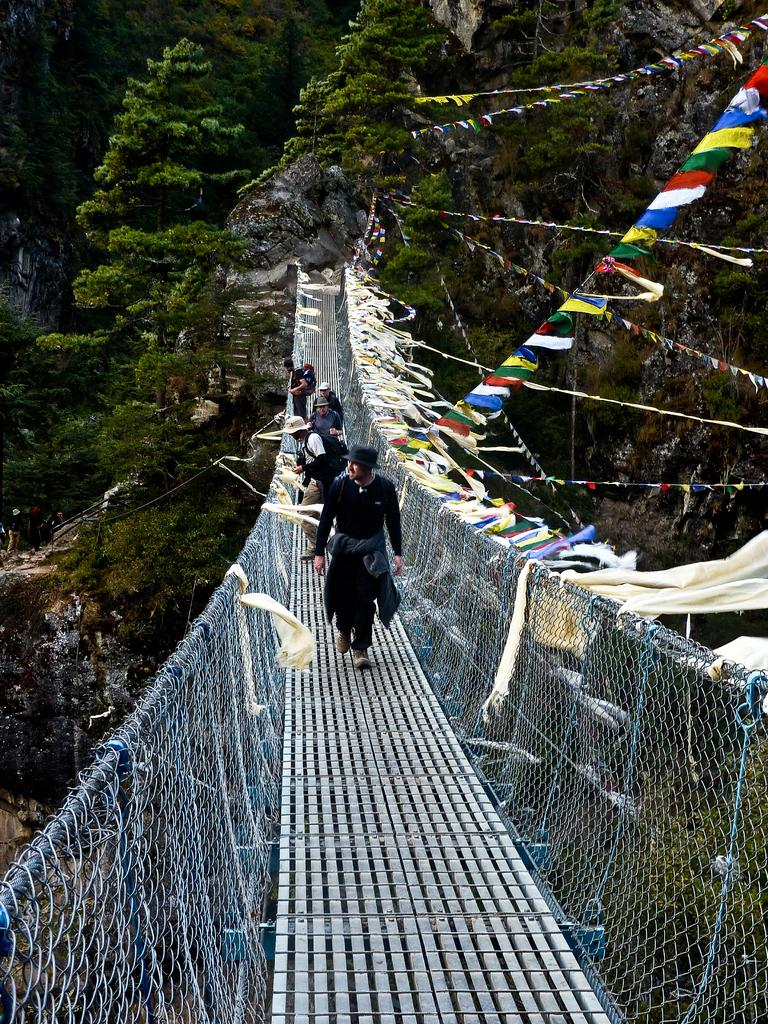What can be seen on the bridge in the image? There are persons on the bridge in the image. What other objects or symbols are present in the image? There are flags in the image. What type of natural scenery is visible in the background of the image? There are trees in the background of the image. Where is the bomb hidden in the image? There is no bomb present in the image. What type of jelly can be seen on the table in the image? There is no table or jelly present in the image. 